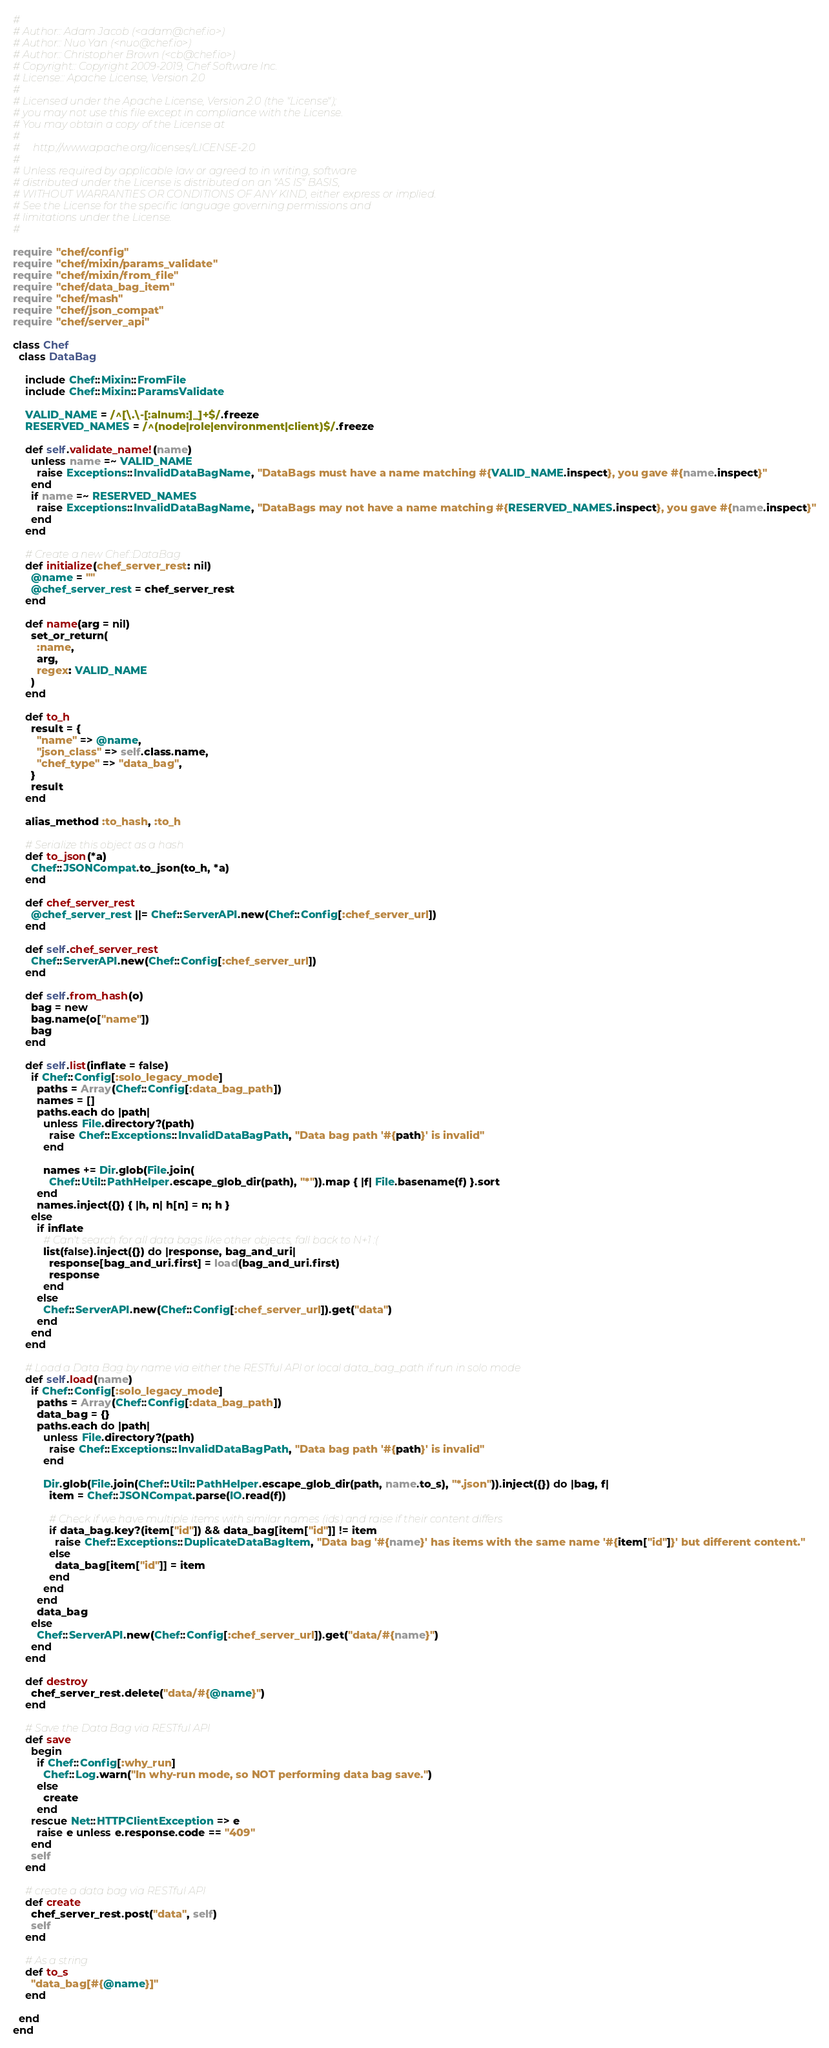<code> <loc_0><loc_0><loc_500><loc_500><_Ruby_>#
# Author:: Adam Jacob (<adam@chef.io>)
# Author:: Nuo Yan (<nuo@chef.io>)
# Author:: Christopher Brown (<cb@chef.io>)
# Copyright:: Copyright 2009-2019, Chef Software Inc.
# License:: Apache License, Version 2.0
#
# Licensed under the Apache License, Version 2.0 (the "License");
# you may not use this file except in compliance with the License.
# You may obtain a copy of the License at
#
#     http://www.apache.org/licenses/LICENSE-2.0
#
# Unless required by applicable law or agreed to in writing, software
# distributed under the License is distributed on an "AS IS" BASIS,
# WITHOUT WARRANTIES OR CONDITIONS OF ANY KIND, either express or implied.
# See the License for the specific language governing permissions and
# limitations under the License.
#

require "chef/config"
require "chef/mixin/params_validate"
require "chef/mixin/from_file"
require "chef/data_bag_item"
require "chef/mash"
require "chef/json_compat"
require "chef/server_api"

class Chef
  class DataBag

    include Chef::Mixin::FromFile
    include Chef::Mixin::ParamsValidate

    VALID_NAME = /^[\.\-[:alnum:]_]+$/.freeze
    RESERVED_NAMES = /^(node|role|environment|client)$/.freeze

    def self.validate_name!(name)
      unless name =~ VALID_NAME
        raise Exceptions::InvalidDataBagName, "DataBags must have a name matching #{VALID_NAME.inspect}, you gave #{name.inspect}"
      end
      if name =~ RESERVED_NAMES
        raise Exceptions::InvalidDataBagName, "DataBags may not have a name matching #{RESERVED_NAMES.inspect}, you gave #{name.inspect}"
      end
    end

    # Create a new Chef::DataBag
    def initialize(chef_server_rest: nil)
      @name = ""
      @chef_server_rest = chef_server_rest
    end

    def name(arg = nil)
      set_or_return(
        :name,
        arg,
        regex: VALID_NAME
      )
    end

    def to_h
      result = {
        "name" => @name,
        "json_class" => self.class.name,
        "chef_type" => "data_bag",
      }
      result
    end

    alias_method :to_hash, :to_h

    # Serialize this object as a hash
    def to_json(*a)
      Chef::JSONCompat.to_json(to_h, *a)
    end

    def chef_server_rest
      @chef_server_rest ||= Chef::ServerAPI.new(Chef::Config[:chef_server_url])
    end

    def self.chef_server_rest
      Chef::ServerAPI.new(Chef::Config[:chef_server_url])
    end

    def self.from_hash(o)
      bag = new
      bag.name(o["name"])
      bag
    end

    def self.list(inflate = false)
      if Chef::Config[:solo_legacy_mode]
        paths = Array(Chef::Config[:data_bag_path])
        names = []
        paths.each do |path|
          unless File.directory?(path)
            raise Chef::Exceptions::InvalidDataBagPath, "Data bag path '#{path}' is invalid"
          end

          names += Dir.glob(File.join(
            Chef::Util::PathHelper.escape_glob_dir(path), "*")).map { |f| File.basename(f) }.sort
        end
        names.inject({}) { |h, n| h[n] = n; h }
      else
        if inflate
          # Can't search for all data bags like other objects, fall back to N+1 :(
          list(false).inject({}) do |response, bag_and_uri|
            response[bag_and_uri.first] = load(bag_and_uri.first)
            response
          end
        else
          Chef::ServerAPI.new(Chef::Config[:chef_server_url]).get("data")
        end
      end
    end

    # Load a Data Bag by name via either the RESTful API or local data_bag_path if run in solo mode
    def self.load(name)
      if Chef::Config[:solo_legacy_mode]
        paths = Array(Chef::Config[:data_bag_path])
        data_bag = {}
        paths.each do |path|
          unless File.directory?(path)
            raise Chef::Exceptions::InvalidDataBagPath, "Data bag path '#{path}' is invalid"
          end

          Dir.glob(File.join(Chef::Util::PathHelper.escape_glob_dir(path, name.to_s), "*.json")).inject({}) do |bag, f|
            item = Chef::JSONCompat.parse(IO.read(f))

            # Check if we have multiple items with similar names (ids) and raise if their content differs
            if data_bag.key?(item["id"]) && data_bag[item["id"]] != item
              raise Chef::Exceptions::DuplicateDataBagItem, "Data bag '#{name}' has items with the same name '#{item["id"]}' but different content."
            else
              data_bag[item["id"]] = item
            end
          end
        end
        data_bag
      else
        Chef::ServerAPI.new(Chef::Config[:chef_server_url]).get("data/#{name}")
      end
    end

    def destroy
      chef_server_rest.delete("data/#{@name}")
    end

    # Save the Data Bag via RESTful API
    def save
      begin
        if Chef::Config[:why_run]
          Chef::Log.warn("In why-run mode, so NOT performing data bag save.")
        else
          create
        end
      rescue Net::HTTPClientException => e
        raise e unless e.response.code == "409"
      end
      self
    end

    # create a data bag via RESTful API
    def create
      chef_server_rest.post("data", self)
      self
    end

    # As a string
    def to_s
      "data_bag[#{@name}]"
    end

  end
end
</code> 